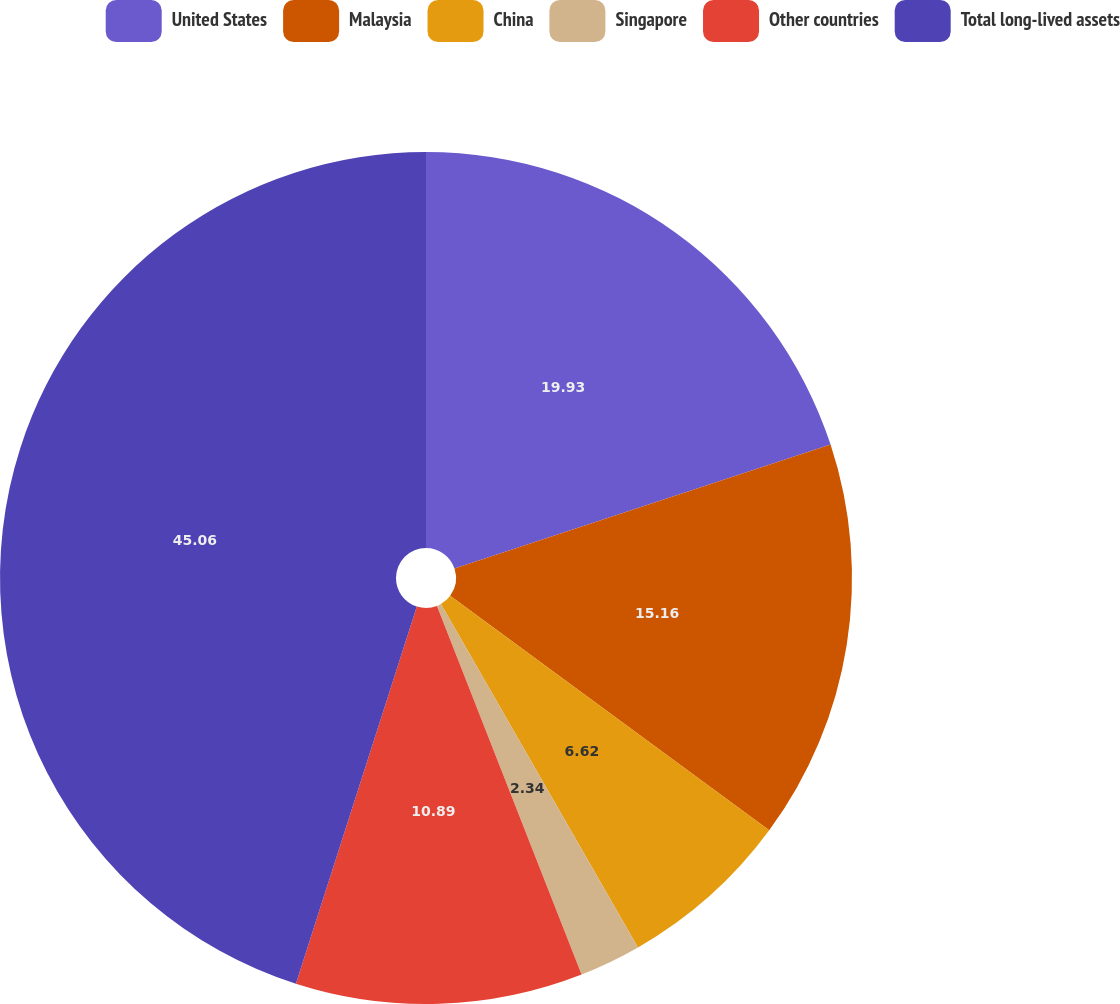<chart> <loc_0><loc_0><loc_500><loc_500><pie_chart><fcel>United States<fcel>Malaysia<fcel>China<fcel>Singapore<fcel>Other countries<fcel>Total long-lived assets<nl><fcel>19.93%<fcel>15.16%<fcel>6.62%<fcel>2.34%<fcel>10.89%<fcel>45.06%<nl></chart> 